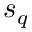<formula> <loc_0><loc_0><loc_500><loc_500>s _ { q }</formula> 